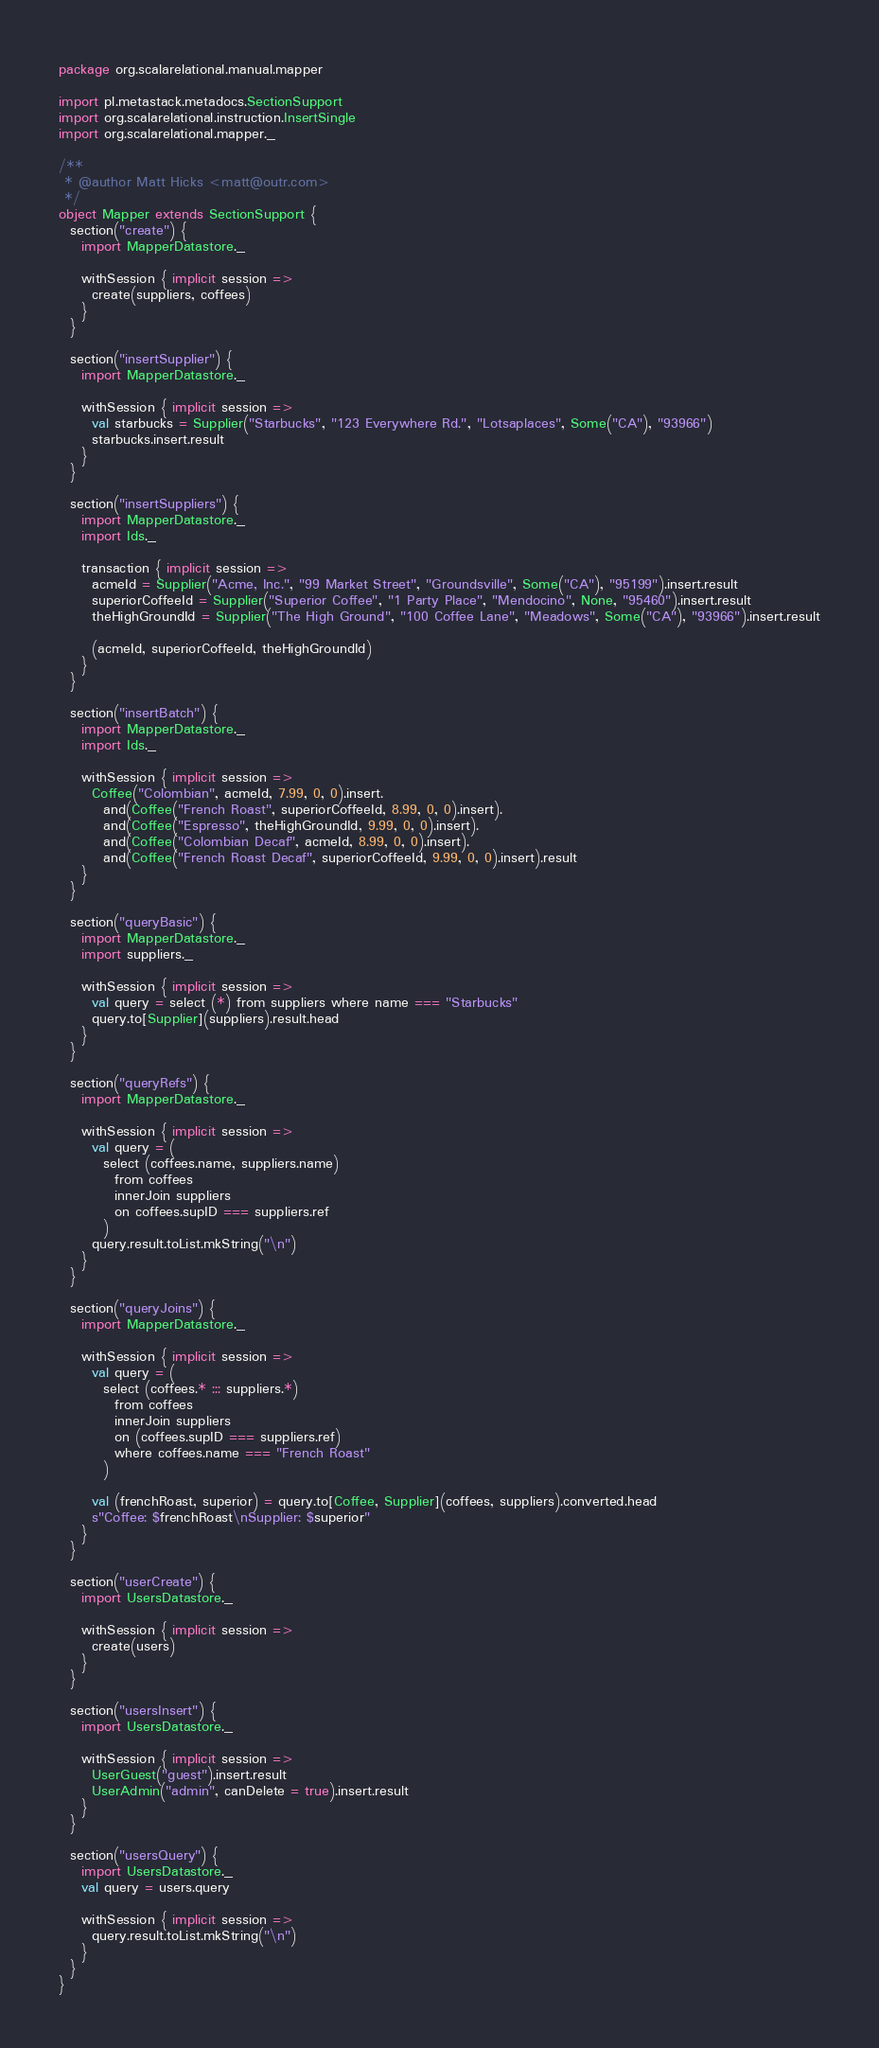Convert code to text. <code><loc_0><loc_0><loc_500><loc_500><_Scala_>package org.scalarelational.manual.mapper

import pl.metastack.metadocs.SectionSupport
import org.scalarelational.instruction.InsertSingle
import org.scalarelational.mapper._

/**
 * @author Matt Hicks <matt@outr.com>
 */
object Mapper extends SectionSupport {
  section("create") {
    import MapperDatastore._

    withSession { implicit session =>
      create(suppliers, coffees)
    }
  }

  section("insertSupplier") {
    import MapperDatastore._

    withSession { implicit session =>
      val starbucks = Supplier("Starbucks", "123 Everywhere Rd.", "Lotsaplaces", Some("CA"), "93966")
      starbucks.insert.result
    }
  }

  section("insertSuppliers") {
    import MapperDatastore._
    import Ids._

    transaction { implicit session =>
      acmeId = Supplier("Acme, Inc.", "99 Market Street", "Groundsville", Some("CA"), "95199").insert.result
      superiorCoffeeId = Supplier("Superior Coffee", "1 Party Place", "Mendocino", None, "95460").insert.result
      theHighGroundId = Supplier("The High Ground", "100 Coffee Lane", "Meadows", Some("CA"), "93966").insert.result

      (acmeId, superiorCoffeeId, theHighGroundId)
    }
  }

  section("insertBatch") {
    import MapperDatastore._
    import Ids._

    withSession { implicit session =>
      Coffee("Colombian", acmeId, 7.99, 0, 0).insert.
        and(Coffee("French Roast", superiorCoffeeId, 8.99, 0, 0).insert).
        and(Coffee("Espresso", theHighGroundId, 9.99, 0, 0).insert).
        and(Coffee("Colombian Decaf", acmeId, 8.99, 0, 0).insert).
        and(Coffee("French Roast Decaf", superiorCoffeeId, 9.99, 0, 0).insert).result
    }
  }

  section("queryBasic") {
    import MapperDatastore._
    import suppliers._

    withSession { implicit session =>
      val query = select (*) from suppliers where name === "Starbucks"
      query.to[Supplier](suppliers).result.head
    }
  }

  section("queryRefs") {
    import MapperDatastore._

    withSession { implicit session =>
      val query = (
        select (coffees.name, suppliers.name)
          from coffees
          innerJoin suppliers
          on coffees.supID === suppliers.ref
        )
      query.result.toList.mkString("\n")
    }
  }

  section("queryJoins") {
    import MapperDatastore._

    withSession { implicit session =>
      val query = (
        select (coffees.* ::: suppliers.*)
          from coffees
          innerJoin suppliers
          on (coffees.supID === suppliers.ref)
          where coffees.name === "French Roast"
        )

      val (frenchRoast, superior) = query.to[Coffee, Supplier](coffees, suppliers).converted.head
      s"Coffee: $frenchRoast\nSupplier: $superior"
    }
  }

  section("userCreate") {
    import UsersDatastore._

    withSession { implicit session =>
      create(users)
    }
  }

  section("usersInsert") {
    import UsersDatastore._

    withSession { implicit session =>
      UserGuest("guest").insert.result
      UserAdmin("admin", canDelete = true).insert.result
    }
  }

  section("usersQuery") {
    import UsersDatastore._
    val query = users.query

    withSession { implicit session =>
      query.result.toList.mkString("\n")
    }
  }
}</code> 